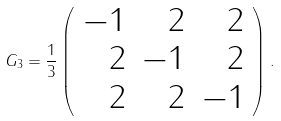Convert formula to latex. <formula><loc_0><loc_0><loc_500><loc_500>G _ { 3 } = \frac { 1 } { 3 } \left ( \begin{array} { r r r } - 1 & 2 & 2 \\ 2 & - 1 & 2 \\ 2 & 2 & - 1 \\ \end{array} \right ) .</formula> 